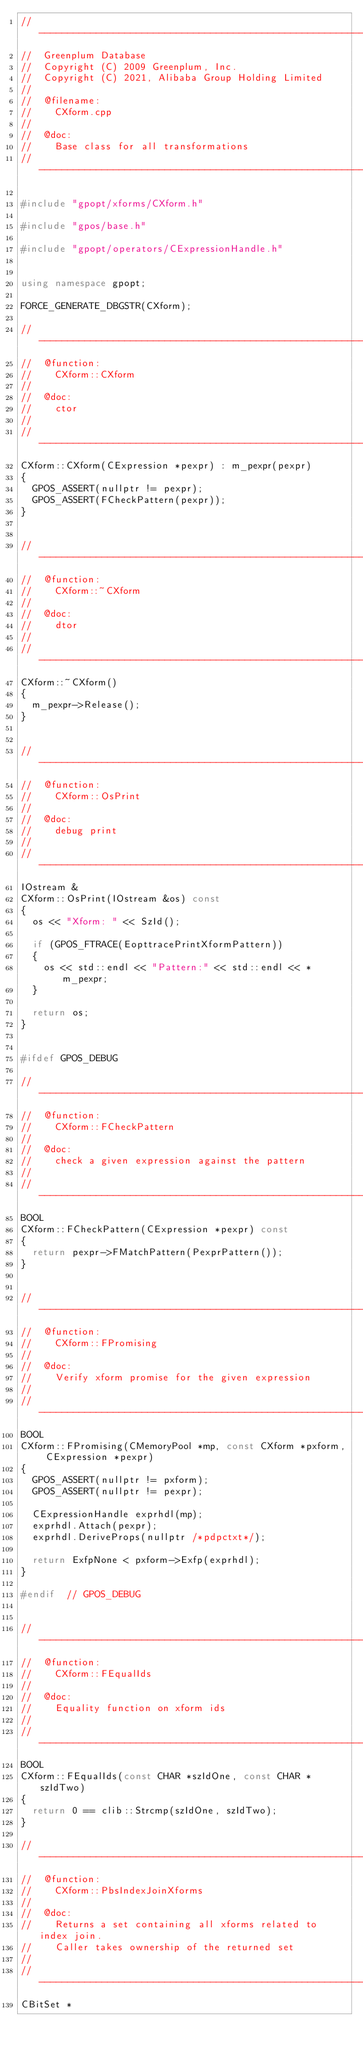<code> <loc_0><loc_0><loc_500><loc_500><_C++_>//---------------------------------------------------------------------------
//	Greenplum Database
//	Copyright (C) 2009 Greenplum, Inc.
//	Copyright (C) 2021, Alibaba Group Holding Limited
//
//	@filename:
//		CXform.cpp
//
//	@doc:
//		Base class for all transformations
//---------------------------------------------------------------------------

#include "gpopt/xforms/CXform.h"

#include "gpos/base.h"

#include "gpopt/operators/CExpressionHandle.h"


using namespace gpopt;

FORCE_GENERATE_DBGSTR(CXform);

//---------------------------------------------------------------------------
//	@function:
//		CXform::CXform
//
//	@doc:
//		ctor
//
//---------------------------------------------------------------------------
CXform::CXform(CExpression *pexpr) : m_pexpr(pexpr)
{
	GPOS_ASSERT(nullptr != pexpr);
	GPOS_ASSERT(FCheckPattern(pexpr));
}


//---------------------------------------------------------------------------
//	@function:
//		CXform::~CXform
//
//	@doc:
//		dtor
//
//---------------------------------------------------------------------------
CXform::~CXform()
{
	m_pexpr->Release();
}


//---------------------------------------------------------------------------
//	@function:
//		CXform::OsPrint
//
//	@doc:
//		debug print
//
//---------------------------------------------------------------------------
IOstream &
CXform::OsPrint(IOstream &os) const
{
	os << "Xform: " << SzId();

	if (GPOS_FTRACE(EopttracePrintXformPattern))
	{
		os << std::endl << "Pattern:" << std::endl << *m_pexpr;
	}

	return os;
}


#ifdef GPOS_DEBUG

//---------------------------------------------------------------------------
//	@function:
//		CXform::FCheckPattern
//
//	@doc:
//		check a given expression against the pattern
//
//---------------------------------------------------------------------------
BOOL
CXform::FCheckPattern(CExpression *pexpr) const
{
	return pexpr->FMatchPattern(PexprPattern());
}


//---------------------------------------------------------------------------
//	@function:
//		CXform::FPromising
//
//	@doc:
//		Verify xform promise for the given expression
//
//---------------------------------------------------------------------------
BOOL
CXform::FPromising(CMemoryPool *mp, const CXform *pxform, CExpression *pexpr)
{
	GPOS_ASSERT(nullptr != pxform);
	GPOS_ASSERT(nullptr != pexpr);

	CExpressionHandle exprhdl(mp);
	exprhdl.Attach(pexpr);
	exprhdl.DeriveProps(nullptr /*pdpctxt*/);

	return ExfpNone < pxform->Exfp(exprhdl);
}

#endif	// GPOS_DEBUG


//---------------------------------------------------------------------------
//	@function:
//		CXform::FEqualIds
//
//	@doc:
//		Equality function on xform ids
//
//---------------------------------------------------------------------------
BOOL
CXform::FEqualIds(const CHAR *szIdOne, const CHAR *szIdTwo)
{
	return 0 == clib::Strcmp(szIdOne, szIdTwo);
}

//---------------------------------------------------------------------------
//	@function:
//		CXform::PbsIndexJoinXforms
//
//	@doc:
//		Returns a set containing all xforms related to index join.
//		Caller takes ownership of the returned set
//
//---------------------------------------------------------------------------
CBitSet *</code> 